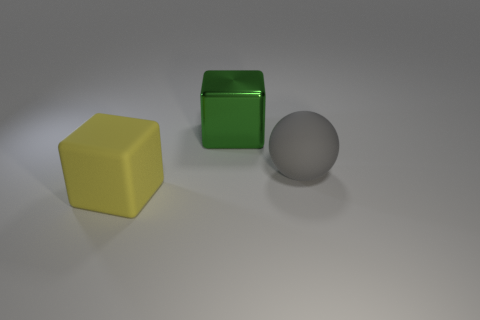Add 3 green objects. How many objects exist? 6 Subtract all green balls. Subtract all purple blocks. How many balls are left? 1 Subtract all spheres. How many objects are left? 2 Add 3 big yellow rubber things. How many big yellow rubber things exist? 4 Subtract 0 blue spheres. How many objects are left? 3 Subtract all green blocks. Subtract all blue metallic cubes. How many objects are left? 2 Add 2 objects. How many objects are left? 5 